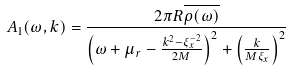Convert formula to latex. <formula><loc_0><loc_0><loc_500><loc_500>A _ { 1 } ( \omega , { k } ) = \frac { 2 \pi R \overline { \rho ( \omega ) } } { \left ( \omega + \mu _ { r } - \frac { { k } ^ { 2 } - \xi _ { x } ^ { - 2 } } { 2 M } \right ) ^ { 2 } + \left ( \frac { k } { M \xi _ { x } } \right ) ^ { 2 } }</formula> 